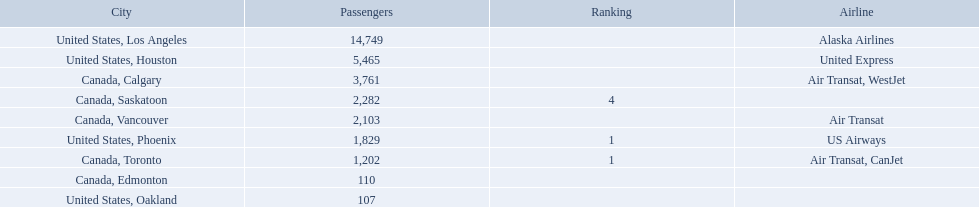Which airport has the least amount of passengers? 107. What airport has 107 passengers? United States, Oakland. Where are the destinations of the airport? United States, Los Angeles, United States, Houston, Canada, Calgary, Canada, Saskatoon, Canada, Vancouver, United States, Phoenix, Canada, Toronto, Canada, Edmonton, United States, Oakland. What is the number of passengers to phoenix? 1,829. 